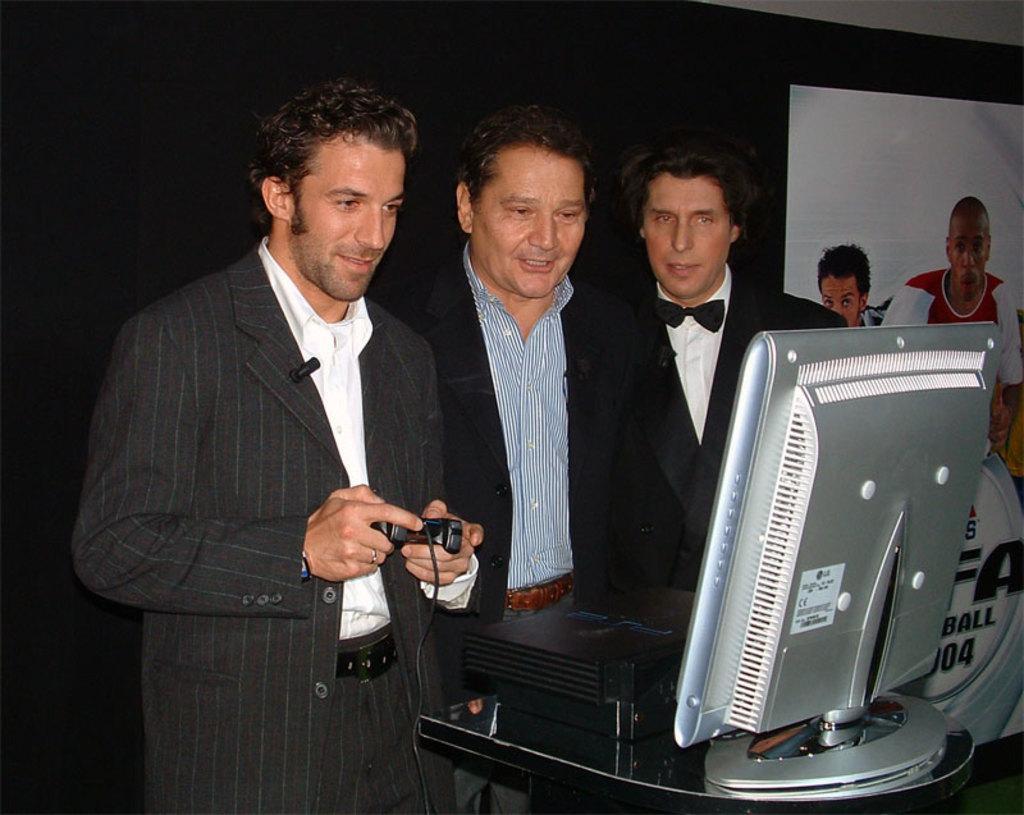Could you give a brief overview of what you see in this image? In the picture we can see three men are standing near the monitor, they are wearing blazers, and one man is holding some part by a wire to it and playing a game on the monitor and behind them, we can see a wall which is black in color with a white color poster and some human images on it. 